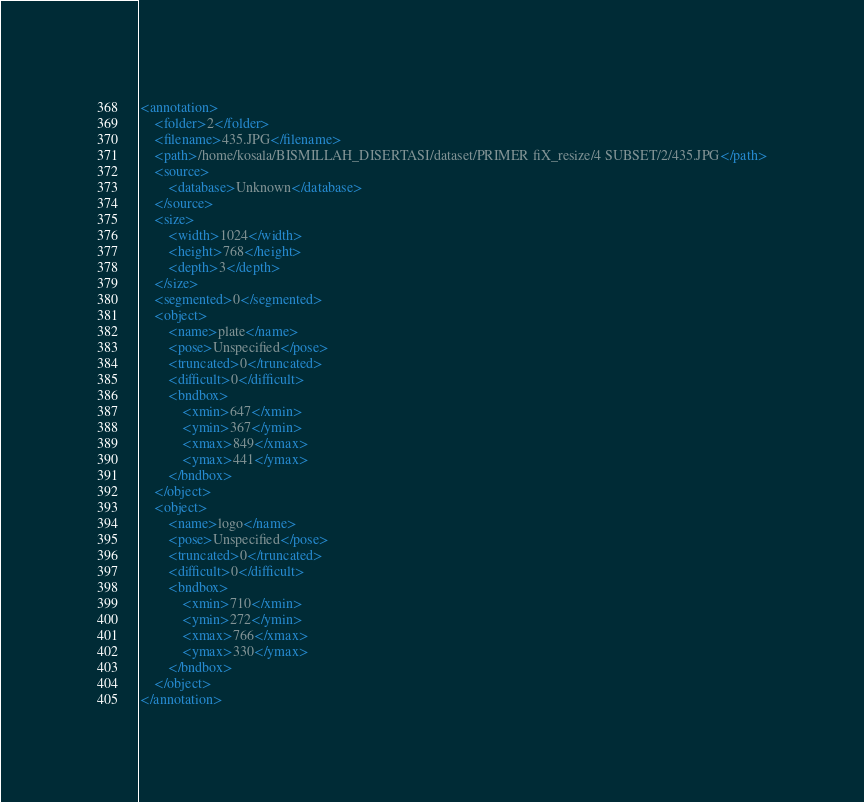Convert code to text. <code><loc_0><loc_0><loc_500><loc_500><_XML_><annotation>
	<folder>2</folder>
	<filename>435.JPG</filename>
	<path>/home/kosala/BISMILLAH_DISERTASI/dataset/PRIMER fiX_resize/4 SUBSET/2/435.JPG</path>
	<source>
		<database>Unknown</database>
	</source>
	<size>
		<width>1024</width>
		<height>768</height>
		<depth>3</depth>
	</size>
	<segmented>0</segmented>
	<object>
		<name>plate</name>
		<pose>Unspecified</pose>
		<truncated>0</truncated>
		<difficult>0</difficult>
		<bndbox>
			<xmin>647</xmin>
			<ymin>367</ymin>
			<xmax>849</xmax>
			<ymax>441</ymax>
		</bndbox>
	</object>
	<object>
		<name>logo</name>
		<pose>Unspecified</pose>
		<truncated>0</truncated>
		<difficult>0</difficult>
		<bndbox>
			<xmin>710</xmin>
			<ymin>272</ymin>
			<xmax>766</xmax>
			<ymax>330</ymax>
		</bndbox>
	</object>
</annotation>
</code> 